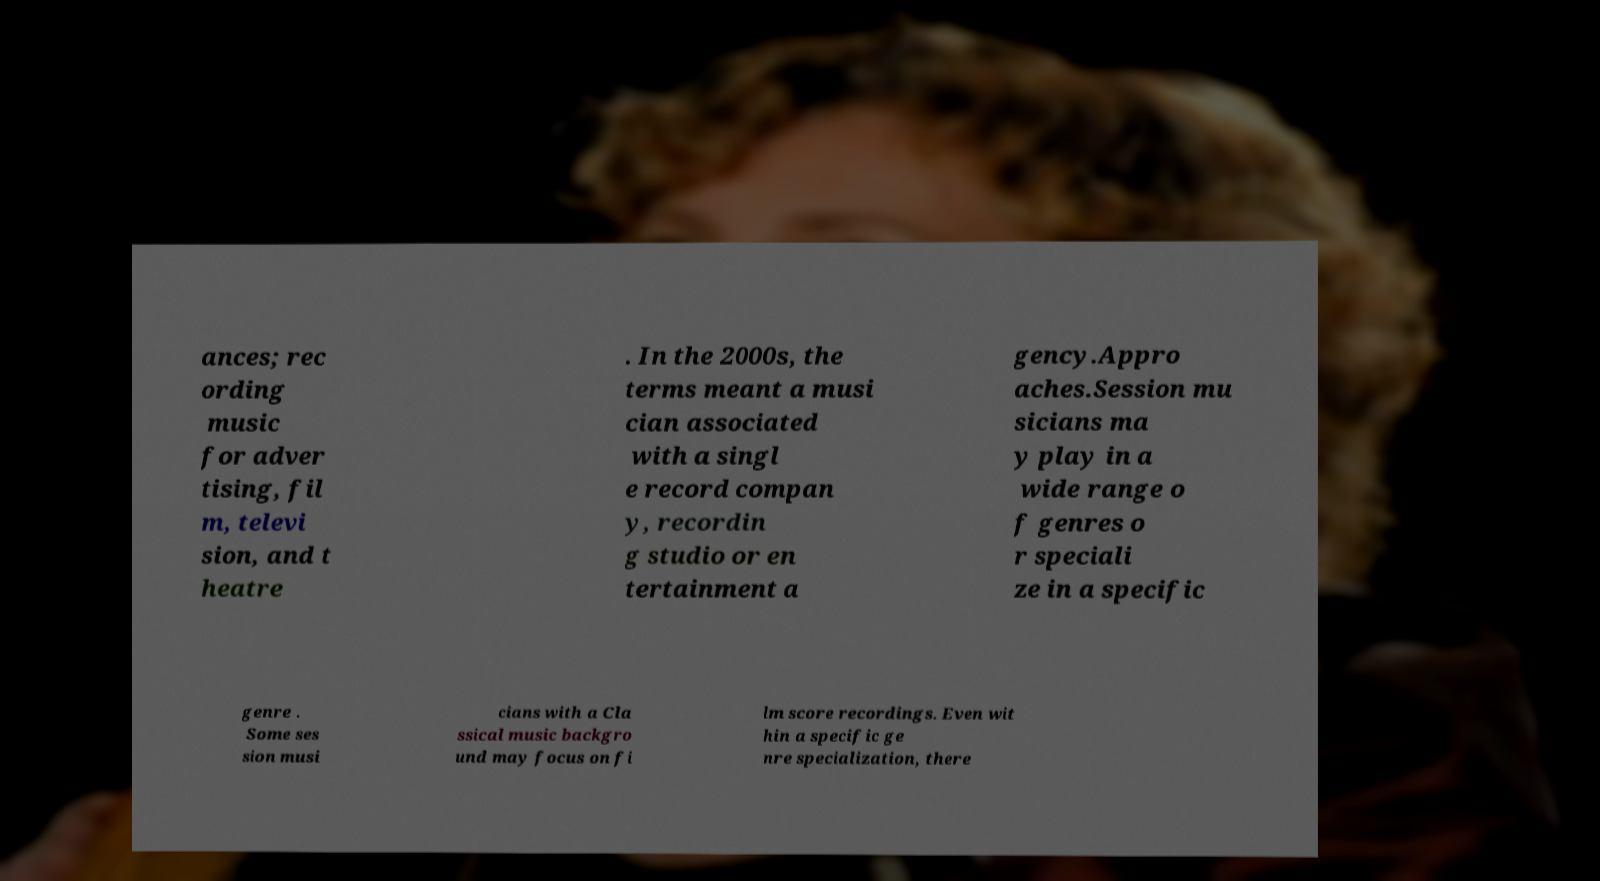Can you read and provide the text displayed in the image?This photo seems to have some interesting text. Can you extract and type it out for me? ances; rec ording music for adver tising, fil m, televi sion, and t heatre . In the 2000s, the terms meant a musi cian associated with a singl e record compan y, recordin g studio or en tertainment a gency.Appro aches.Session mu sicians ma y play in a wide range o f genres o r speciali ze in a specific genre . Some ses sion musi cians with a Cla ssical music backgro und may focus on fi lm score recordings. Even wit hin a specific ge nre specialization, there 